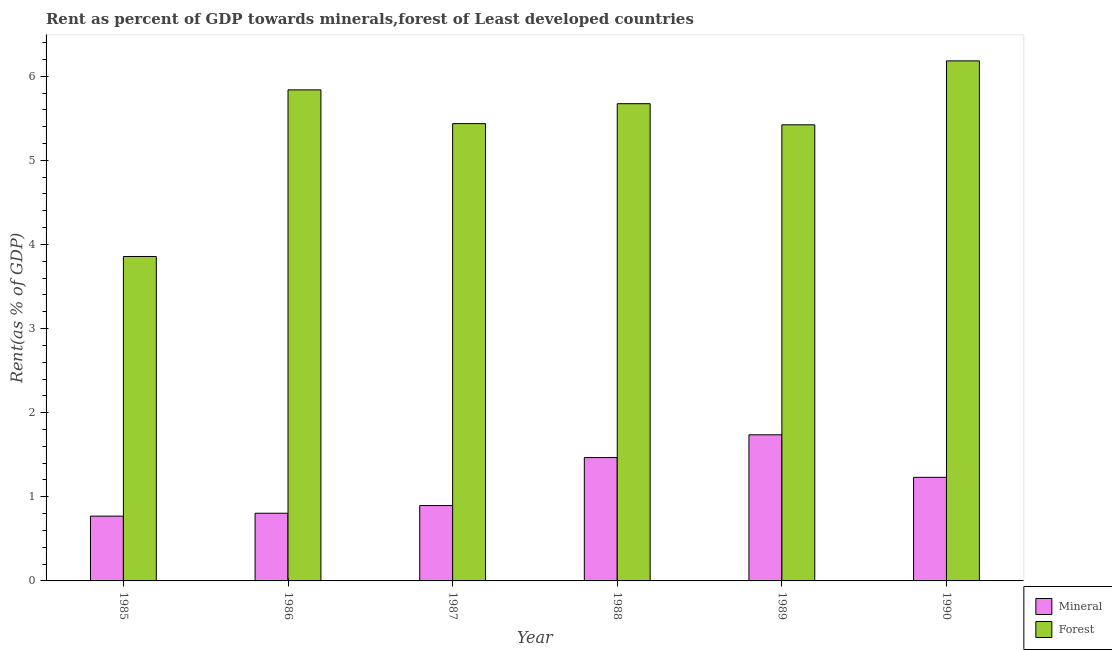How many groups of bars are there?
Ensure brevity in your answer.  6. Are the number of bars per tick equal to the number of legend labels?
Provide a succinct answer. Yes. Are the number of bars on each tick of the X-axis equal?
Your response must be concise. Yes. How many bars are there on the 3rd tick from the right?
Your answer should be very brief. 2. What is the label of the 3rd group of bars from the left?
Offer a terse response. 1987. What is the forest rent in 1989?
Provide a short and direct response. 5.42. Across all years, what is the maximum mineral rent?
Your answer should be compact. 1.74. Across all years, what is the minimum forest rent?
Ensure brevity in your answer.  3.86. In which year was the mineral rent maximum?
Keep it short and to the point. 1989. What is the total forest rent in the graph?
Your response must be concise. 32.41. What is the difference between the forest rent in 1989 and that in 1990?
Offer a terse response. -0.76. What is the difference between the forest rent in 1990 and the mineral rent in 1985?
Your answer should be compact. 2.33. What is the average forest rent per year?
Provide a short and direct response. 5.4. In the year 1987, what is the difference between the mineral rent and forest rent?
Provide a short and direct response. 0. What is the ratio of the mineral rent in 1987 to that in 1990?
Make the answer very short. 0.73. Is the forest rent in 1987 less than that in 1990?
Offer a very short reply. Yes. What is the difference between the highest and the second highest mineral rent?
Provide a short and direct response. 0.27. What is the difference between the highest and the lowest forest rent?
Offer a terse response. 2.33. Is the sum of the mineral rent in 1986 and 1990 greater than the maximum forest rent across all years?
Your answer should be very brief. Yes. What does the 2nd bar from the left in 1986 represents?
Provide a short and direct response. Forest. What does the 2nd bar from the right in 1986 represents?
Provide a short and direct response. Mineral. How many years are there in the graph?
Make the answer very short. 6. Are the values on the major ticks of Y-axis written in scientific E-notation?
Offer a very short reply. No. Does the graph contain any zero values?
Your answer should be very brief. No. Does the graph contain grids?
Provide a short and direct response. No. Where does the legend appear in the graph?
Provide a succinct answer. Bottom right. What is the title of the graph?
Make the answer very short. Rent as percent of GDP towards minerals,forest of Least developed countries. What is the label or title of the X-axis?
Your answer should be very brief. Year. What is the label or title of the Y-axis?
Provide a short and direct response. Rent(as % of GDP). What is the Rent(as % of GDP) of Mineral in 1985?
Make the answer very short. 0.77. What is the Rent(as % of GDP) in Forest in 1985?
Provide a short and direct response. 3.86. What is the Rent(as % of GDP) in Mineral in 1986?
Provide a succinct answer. 0.8. What is the Rent(as % of GDP) of Forest in 1986?
Your response must be concise. 5.84. What is the Rent(as % of GDP) in Mineral in 1987?
Ensure brevity in your answer.  0.9. What is the Rent(as % of GDP) in Forest in 1987?
Provide a succinct answer. 5.44. What is the Rent(as % of GDP) in Mineral in 1988?
Make the answer very short. 1.47. What is the Rent(as % of GDP) of Forest in 1988?
Make the answer very short. 5.67. What is the Rent(as % of GDP) in Mineral in 1989?
Offer a very short reply. 1.74. What is the Rent(as % of GDP) in Forest in 1989?
Your response must be concise. 5.42. What is the Rent(as % of GDP) of Mineral in 1990?
Provide a short and direct response. 1.23. What is the Rent(as % of GDP) of Forest in 1990?
Provide a succinct answer. 6.18. Across all years, what is the maximum Rent(as % of GDP) of Mineral?
Your response must be concise. 1.74. Across all years, what is the maximum Rent(as % of GDP) in Forest?
Your answer should be very brief. 6.18. Across all years, what is the minimum Rent(as % of GDP) in Mineral?
Offer a terse response. 0.77. Across all years, what is the minimum Rent(as % of GDP) in Forest?
Your answer should be compact. 3.86. What is the total Rent(as % of GDP) of Mineral in the graph?
Your answer should be compact. 6.91. What is the total Rent(as % of GDP) of Forest in the graph?
Give a very brief answer. 32.41. What is the difference between the Rent(as % of GDP) of Mineral in 1985 and that in 1986?
Your answer should be very brief. -0.03. What is the difference between the Rent(as % of GDP) in Forest in 1985 and that in 1986?
Your answer should be very brief. -1.98. What is the difference between the Rent(as % of GDP) of Mineral in 1985 and that in 1987?
Your answer should be very brief. -0.13. What is the difference between the Rent(as % of GDP) in Forest in 1985 and that in 1987?
Your answer should be compact. -1.58. What is the difference between the Rent(as % of GDP) of Mineral in 1985 and that in 1988?
Your answer should be compact. -0.7. What is the difference between the Rent(as % of GDP) in Forest in 1985 and that in 1988?
Provide a short and direct response. -1.82. What is the difference between the Rent(as % of GDP) in Mineral in 1985 and that in 1989?
Offer a terse response. -0.97. What is the difference between the Rent(as % of GDP) of Forest in 1985 and that in 1989?
Make the answer very short. -1.57. What is the difference between the Rent(as % of GDP) of Mineral in 1985 and that in 1990?
Give a very brief answer. -0.46. What is the difference between the Rent(as % of GDP) in Forest in 1985 and that in 1990?
Your answer should be very brief. -2.33. What is the difference between the Rent(as % of GDP) of Mineral in 1986 and that in 1987?
Make the answer very short. -0.09. What is the difference between the Rent(as % of GDP) in Forest in 1986 and that in 1987?
Your answer should be compact. 0.4. What is the difference between the Rent(as % of GDP) in Mineral in 1986 and that in 1988?
Give a very brief answer. -0.66. What is the difference between the Rent(as % of GDP) in Forest in 1986 and that in 1988?
Offer a very short reply. 0.16. What is the difference between the Rent(as % of GDP) in Mineral in 1986 and that in 1989?
Give a very brief answer. -0.93. What is the difference between the Rent(as % of GDP) of Forest in 1986 and that in 1989?
Your answer should be very brief. 0.42. What is the difference between the Rent(as % of GDP) of Mineral in 1986 and that in 1990?
Keep it short and to the point. -0.43. What is the difference between the Rent(as % of GDP) of Forest in 1986 and that in 1990?
Make the answer very short. -0.34. What is the difference between the Rent(as % of GDP) in Mineral in 1987 and that in 1988?
Keep it short and to the point. -0.57. What is the difference between the Rent(as % of GDP) of Forest in 1987 and that in 1988?
Your answer should be very brief. -0.24. What is the difference between the Rent(as % of GDP) in Mineral in 1987 and that in 1989?
Offer a terse response. -0.84. What is the difference between the Rent(as % of GDP) of Forest in 1987 and that in 1989?
Keep it short and to the point. 0.01. What is the difference between the Rent(as % of GDP) in Mineral in 1987 and that in 1990?
Your response must be concise. -0.34. What is the difference between the Rent(as % of GDP) of Forest in 1987 and that in 1990?
Your answer should be very brief. -0.75. What is the difference between the Rent(as % of GDP) of Mineral in 1988 and that in 1989?
Ensure brevity in your answer.  -0.27. What is the difference between the Rent(as % of GDP) of Forest in 1988 and that in 1989?
Make the answer very short. 0.25. What is the difference between the Rent(as % of GDP) in Mineral in 1988 and that in 1990?
Give a very brief answer. 0.23. What is the difference between the Rent(as % of GDP) of Forest in 1988 and that in 1990?
Your answer should be very brief. -0.51. What is the difference between the Rent(as % of GDP) of Mineral in 1989 and that in 1990?
Offer a very short reply. 0.51. What is the difference between the Rent(as % of GDP) in Forest in 1989 and that in 1990?
Your response must be concise. -0.76. What is the difference between the Rent(as % of GDP) of Mineral in 1985 and the Rent(as % of GDP) of Forest in 1986?
Your response must be concise. -5.07. What is the difference between the Rent(as % of GDP) of Mineral in 1985 and the Rent(as % of GDP) of Forest in 1987?
Make the answer very short. -4.67. What is the difference between the Rent(as % of GDP) in Mineral in 1985 and the Rent(as % of GDP) in Forest in 1988?
Your answer should be compact. -4.9. What is the difference between the Rent(as % of GDP) of Mineral in 1985 and the Rent(as % of GDP) of Forest in 1989?
Your response must be concise. -4.65. What is the difference between the Rent(as % of GDP) in Mineral in 1985 and the Rent(as % of GDP) in Forest in 1990?
Your answer should be compact. -5.41. What is the difference between the Rent(as % of GDP) of Mineral in 1986 and the Rent(as % of GDP) of Forest in 1987?
Offer a very short reply. -4.63. What is the difference between the Rent(as % of GDP) of Mineral in 1986 and the Rent(as % of GDP) of Forest in 1988?
Give a very brief answer. -4.87. What is the difference between the Rent(as % of GDP) of Mineral in 1986 and the Rent(as % of GDP) of Forest in 1989?
Offer a terse response. -4.62. What is the difference between the Rent(as % of GDP) in Mineral in 1986 and the Rent(as % of GDP) in Forest in 1990?
Make the answer very short. -5.38. What is the difference between the Rent(as % of GDP) of Mineral in 1987 and the Rent(as % of GDP) of Forest in 1988?
Make the answer very short. -4.78. What is the difference between the Rent(as % of GDP) of Mineral in 1987 and the Rent(as % of GDP) of Forest in 1989?
Make the answer very short. -4.53. What is the difference between the Rent(as % of GDP) of Mineral in 1987 and the Rent(as % of GDP) of Forest in 1990?
Your response must be concise. -5.29. What is the difference between the Rent(as % of GDP) in Mineral in 1988 and the Rent(as % of GDP) in Forest in 1989?
Your response must be concise. -3.96. What is the difference between the Rent(as % of GDP) of Mineral in 1988 and the Rent(as % of GDP) of Forest in 1990?
Your answer should be very brief. -4.72. What is the difference between the Rent(as % of GDP) of Mineral in 1989 and the Rent(as % of GDP) of Forest in 1990?
Your answer should be compact. -4.44. What is the average Rent(as % of GDP) in Mineral per year?
Offer a terse response. 1.15. What is the average Rent(as % of GDP) of Forest per year?
Ensure brevity in your answer.  5.4. In the year 1985, what is the difference between the Rent(as % of GDP) in Mineral and Rent(as % of GDP) in Forest?
Give a very brief answer. -3.09. In the year 1986, what is the difference between the Rent(as % of GDP) of Mineral and Rent(as % of GDP) of Forest?
Offer a terse response. -5.03. In the year 1987, what is the difference between the Rent(as % of GDP) of Mineral and Rent(as % of GDP) of Forest?
Your answer should be compact. -4.54. In the year 1988, what is the difference between the Rent(as % of GDP) of Mineral and Rent(as % of GDP) of Forest?
Your response must be concise. -4.21. In the year 1989, what is the difference between the Rent(as % of GDP) in Mineral and Rent(as % of GDP) in Forest?
Make the answer very short. -3.68. In the year 1990, what is the difference between the Rent(as % of GDP) in Mineral and Rent(as % of GDP) in Forest?
Keep it short and to the point. -4.95. What is the ratio of the Rent(as % of GDP) of Mineral in 1985 to that in 1986?
Provide a short and direct response. 0.96. What is the ratio of the Rent(as % of GDP) in Forest in 1985 to that in 1986?
Give a very brief answer. 0.66. What is the ratio of the Rent(as % of GDP) of Mineral in 1985 to that in 1987?
Provide a short and direct response. 0.86. What is the ratio of the Rent(as % of GDP) of Forest in 1985 to that in 1987?
Keep it short and to the point. 0.71. What is the ratio of the Rent(as % of GDP) of Mineral in 1985 to that in 1988?
Your answer should be compact. 0.53. What is the ratio of the Rent(as % of GDP) of Forest in 1985 to that in 1988?
Your answer should be very brief. 0.68. What is the ratio of the Rent(as % of GDP) of Mineral in 1985 to that in 1989?
Offer a terse response. 0.44. What is the ratio of the Rent(as % of GDP) in Forest in 1985 to that in 1989?
Provide a succinct answer. 0.71. What is the ratio of the Rent(as % of GDP) of Mineral in 1985 to that in 1990?
Give a very brief answer. 0.63. What is the ratio of the Rent(as % of GDP) of Forest in 1985 to that in 1990?
Your answer should be compact. 0.62. What is the ratio of the Rent(as % of GDP) in Mineral in 1986 to that in 1987?
Give a very brief answer. 0.9. What is the ratio of the Rent(as % of GDP) in Forest in 1986 to that in 1987?
Make the answer very short. 1.07. What is the ratio of the Rent(as % of GDP) of Mineral in 1986 to that in 1988?
Your response must be concise. 0.55. What is the ratio of the Rent(as % of GDP) in Forest in 1986 to that in 1988?
Your answer should be compact. 1.03. What is the ratio of the Rent(as % of GDP) in Mineral in 1986 to that in 1989?
Ensure brevity in your answer.  0.46. What is the ratio of the Rent(as % of GDP) in Forest in 1986 to that in 1989?
Your answer should be very brief. 1.08. What is the ratio of the Rent(as % of GDP) in Mineral in 1986 to that in 1990?
Your answer should be very brief. 0.65. What is the ratio of the Rent(as % of GDP) in Forest in 1986 to that in 1990?
Ensure brevity in your answer.  0.94. What is the ratio of the Rent(as % of GDP) of Mineral in 1987 to that in 1988?
Give a very brief answer. 0.61. What is the ratio of the Rent(as % of GDP) of Forest in 1987 to that in 1988?
Ensure brevity in your answer.  0.96. What is the ratio of the Rent(as % of GDP) of Mineral in 1987 to that in 1989?
Offer a terse response. 0.52. What is the ratio of the Rent(as % of GDP) of Mineral in 1987 to that in 1990?
Make the answer very short. 0.73. What is the ratio of the Rent(as % of GDP) in Forest in 1987 to that in 1990?
Your response must be concise. 0.88. What is the ratio of the Rent(as % of GDP) in Mineral in 1988 to that in 1989?
Your response must be concise. 0.84. What is the ratio of the Rent(as % of GDP) of Forest in 1988 to that in 1989?
Your response must be concise. 1.05. What is the ratio of the Rent(as % of GDP) in Mineral in 1988 to that in 1990?
Keep it short and to the point. 1.19. What is the ratio of the Rent(as % of GDP) in Forest in 1988 to that in 1990?
Ensure brevity in your answer.  0.92. What is the ratio of the Rent(as % of GDP) of Mineral in 1989 to that in 1990?
Provide a short and direct response. 1.41. What is the ratio of the Rent(as % of GDP) of Forest in 1989 to that in 1990?
Your response must be concise. 0.88. What is the difference between the highest and the second highest Rent(as % of GDP) in Mineral?
Provide a short and direct response. 0.27. What is the difference between the highest and the second highest Rent(as % of GDP) in Forest?
Offer a very short reply. 0.34. What is the difference between the highest and the lowest Rent(as % of GDP) in Forest?
Offer a very short reply. 2.33. 